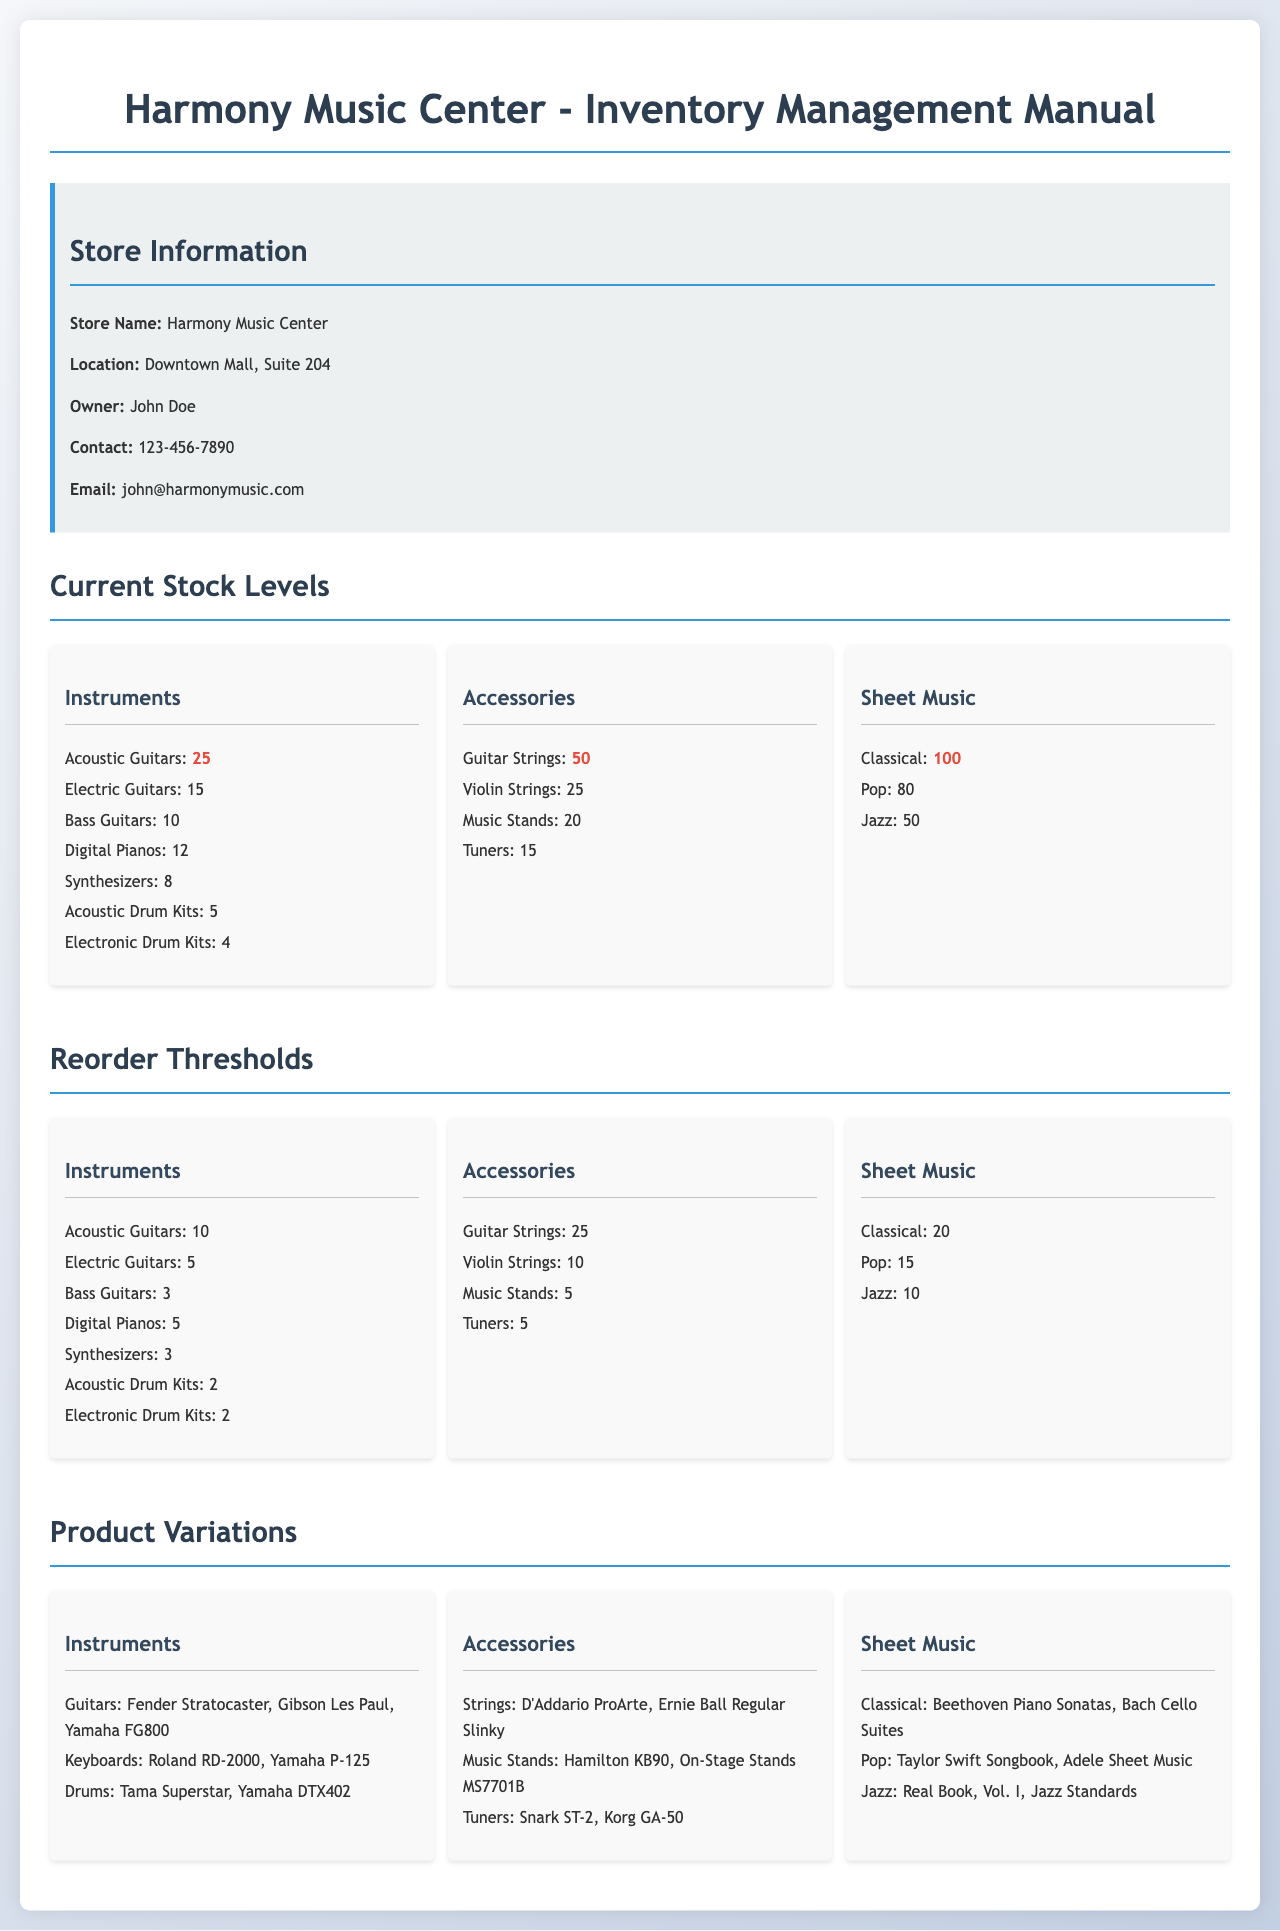What is the current stock level for Acoustic Guitars? The current stock level for Acoustic Guitars is listed as 25 in the document.
Answer: 25 What is the reorder threshold for Music Stands? The reorder threshold for Music Stands is specified in the document as 5.
Answer: 5 How many different types of Electric Guitars are mentioned? The document lists only one type of Electric Guitar, which is 'Electric Guitars'.
Answer: 1 Which instrument has the lowest current stock level? The instrument with the lowest current stock level listed in the document is Electronic Drum Kits with 4.
Answer: Electronic Drum Kits What are two variations of Guitar Strings mentioned in the document? The document provides two variations of Guitar Strings: D'Addario ProArte and Ernie Ball Regular Slinky.
Answer: D'Addario ProArte, Ernie Ball Regular Slinky What is the total current stock for Sheet Music? The total current stock for Sheet Music can be calculated by summing the individual stocks: 100 + 80 + 50 = 230.
Answer: 230 What are two variations of Classical Sheet Music mentioned? The document mentions two variations of Classical Sheet Music: Beethoven Piano Sonatas and Bach Cello Suites.
Answer: Beethoven Piano Sonatas, Bach Cello Suites What is the owner’s name of Harmony Music Center? The owner's name is John Doe, as stated in the document.
Answer: John Doe 